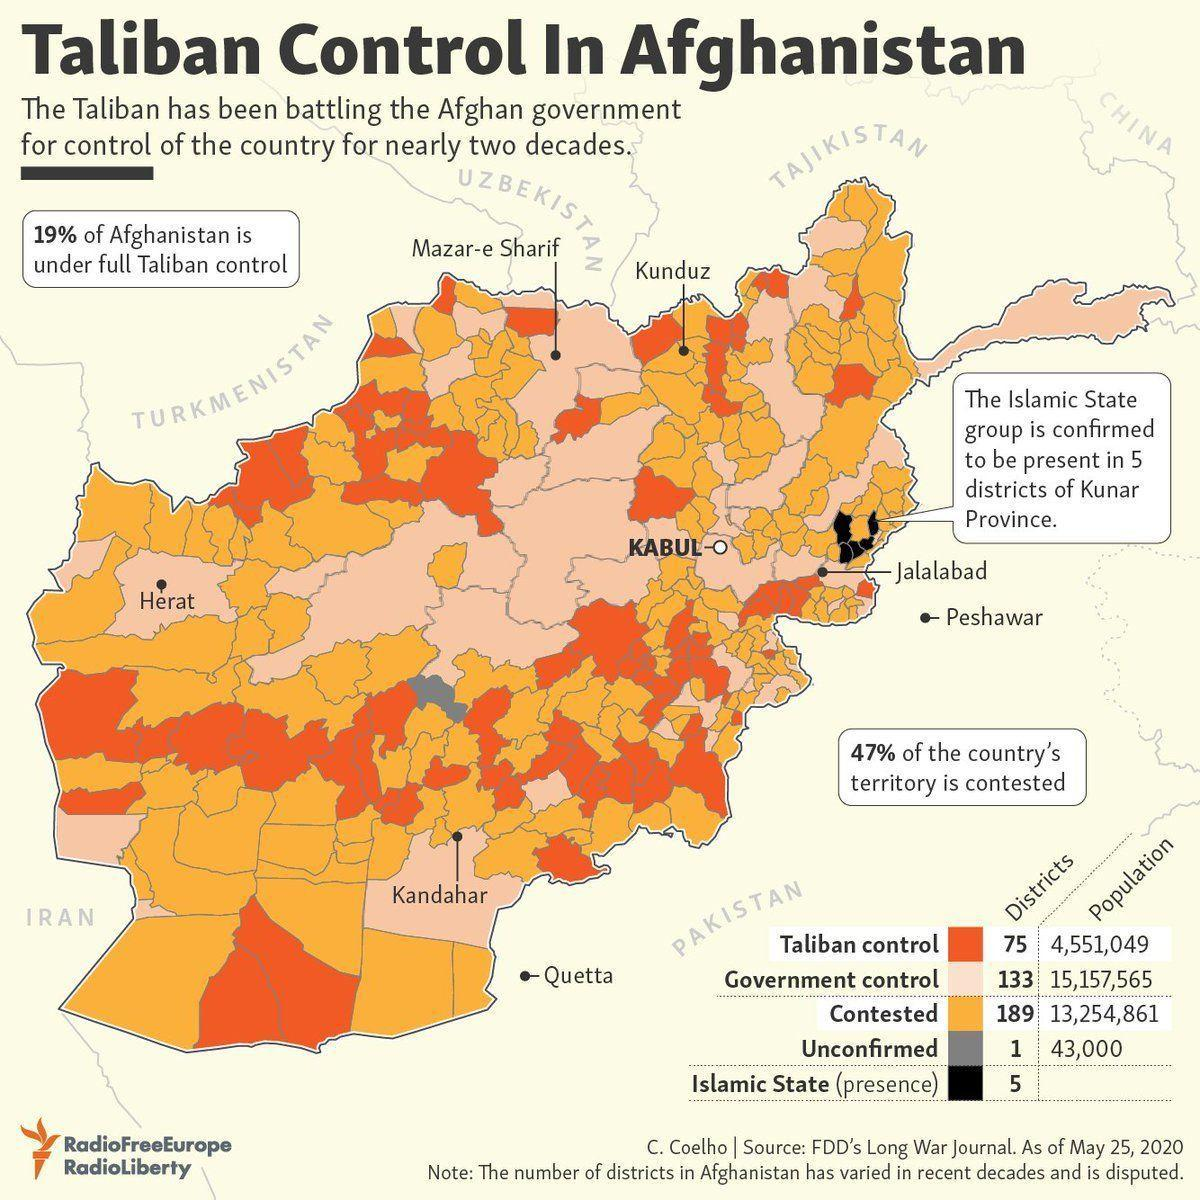Which city in the northern region is shown in the map in contested territory?
Answer the question with a short phrase. Kunduz Which city shown in the map is closest to area under control of Islamic State? Jalalabad Which is the city shown in the map in the western region? Herat Which city in Southern region of Afghanistan is shown in the map? Kandahar Is the city of Kabul located in government control or contested territory? government control Which northern city is shown in the map in government controlled territory? Mazar-e-Sharif 